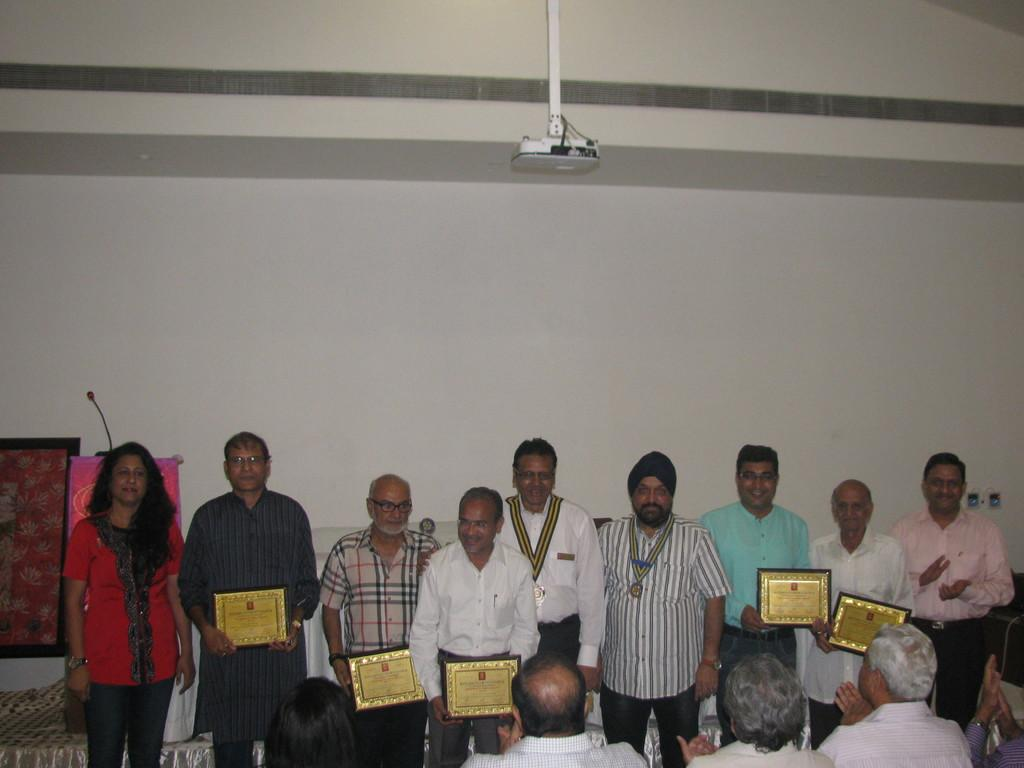What are the people in the image doing? The people in the image are standing and holding frames. Are there any other people in the image? Yes, there are people in front of the standing individuals. What can be seen in the background of the image? There is a board attached to a wall in the background of the image. What type of lace is being used to hold the frames in the image? There is no lace present in the image; the frames are being held by people. How many people are biting the frames in the image? There are no people biting the frames in the image; they are holding them with their hands. 